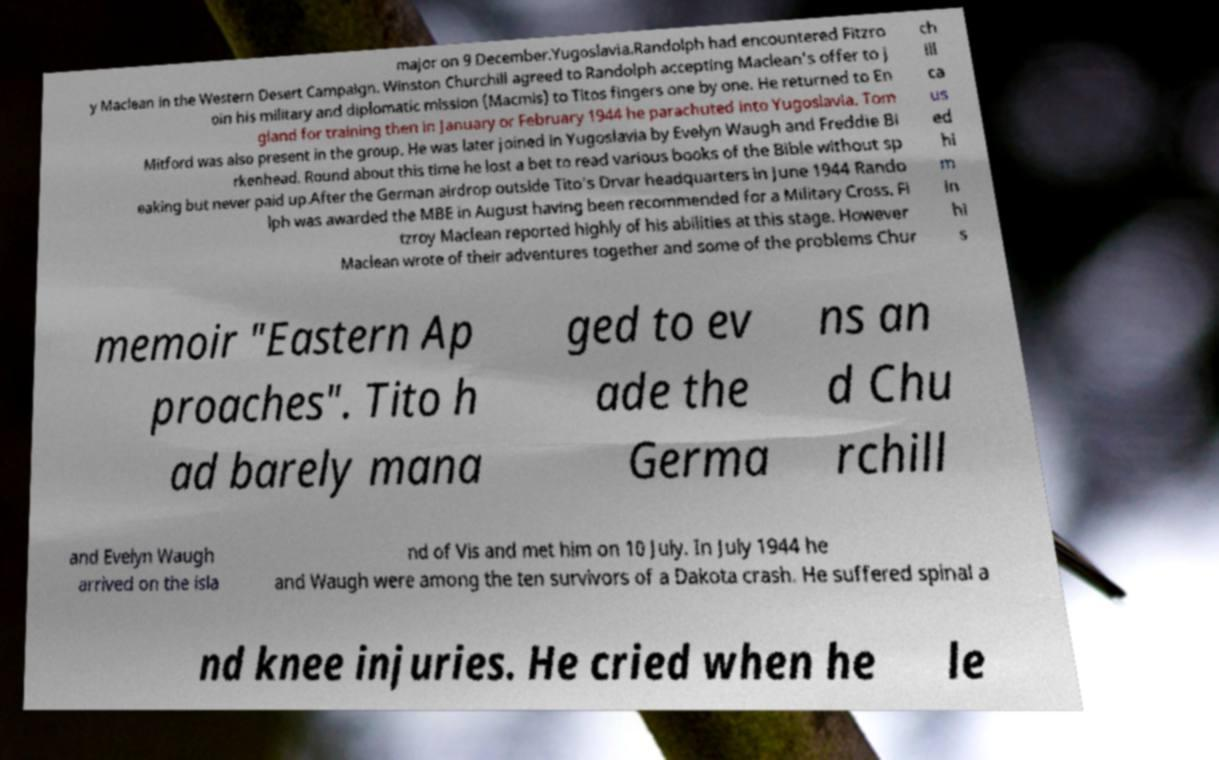I need the written content from this picture converted into text. Can you do that? major on 9 December.Yugoslavia.Randolph had encountered Fitzro y Maclean in the Western Desert Campaign. Winston Churchill agreed to Randolph accepting Maclean's offer to j oin his military and diplomatic mission (Macmis) to Titos fingers one by one. He returned to En gland for training then in January or February 1944 he parachuted into Yugoslavia. Tom Mitford was also present in the group. He was later joined in Yugoslavia by Evelyn Waugh and Freddie Bi rkenhead. Round about this time he lost a bet to read various books of the Bible without sp eaking but never paid up.After the German airdrop outside Tito's Drvar headquarters in June 1944 Rando lph was awarded the MBE in August having been recommended for a Military Cross. Fi tzroy Maclean reported highly of his abilities at this stage. However Maclean wrote of their adventures together and some of the problems Chur ch ill ca us ed hi m in hi s memoir "Eastern Ap proaches". Tito h ad barely mana ged to ev ade the Germa ns an d Chu rchill and Evelyn Waugh arrived on the isla nd of Vis and met him on 10 July. In July 1944 he and Waugh were among the ten survivors of a Dakota crash. He suffered spinal a nd knee injuries. He cried when he le 